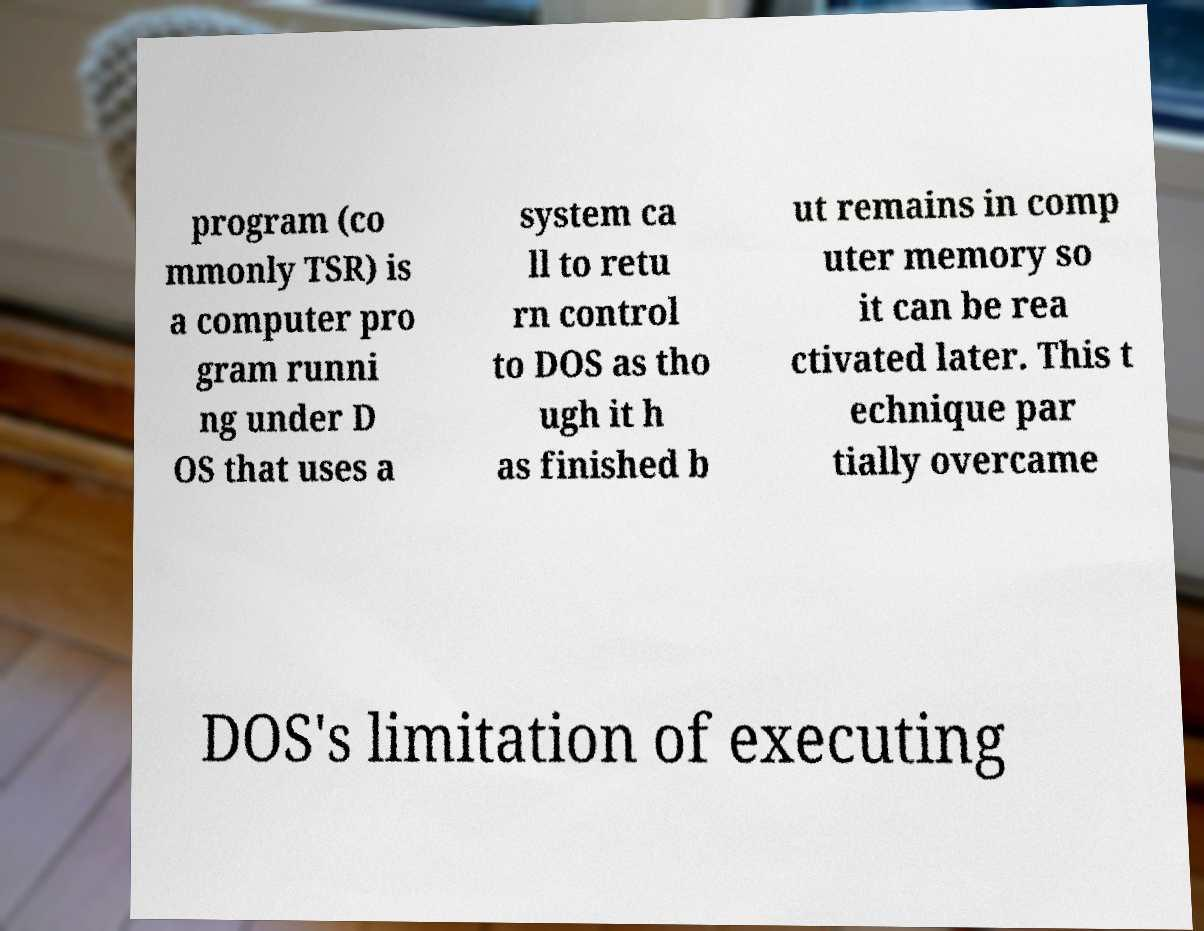Can you accurately transcribe the text from the provided image for me? program (co mmonly TSR) is a computer pro gram runni ng under D OS that uses a system ca ll to retu rn control to DOS as tho ugh it h as finished b ut remains in comp uter memory so it can be rea ctivated later. This t echnique par tially overcame DOS's limitation of executing 